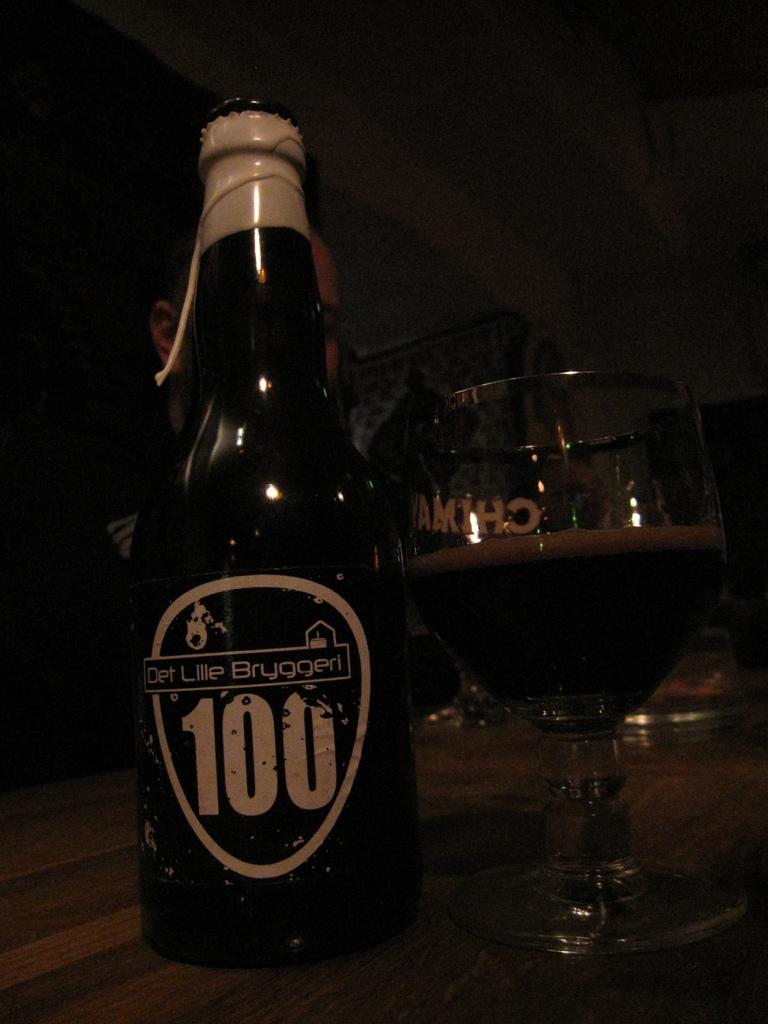<image>
Share a concise interpretation of the image provided. Dark Det Lille Bryggeri beer bottle next to a cup of beer. 